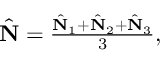Convert formula to latex. <formula><loc_0><loc_0><loc_500><loc_500>\begin{array} { r } { \hat { N } = \frac { \hat { N } _ { 1 } + \hat { N } _ { 2 } + \hat { N } _ { 3 } } { 3 } , } \end{array}</formula> 